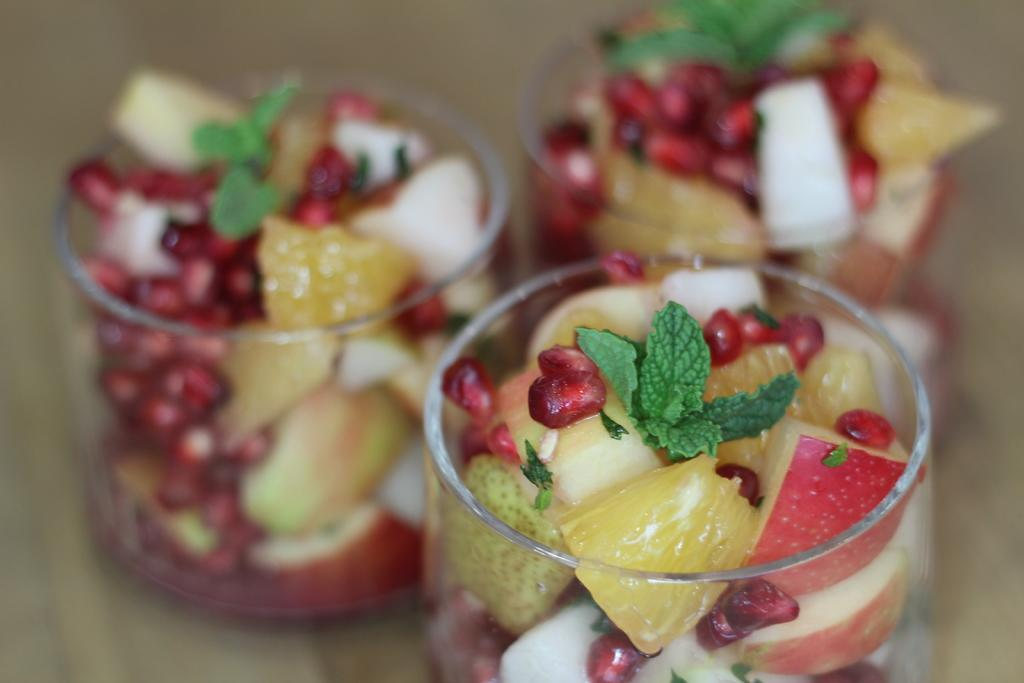How many bowls are visible in the image? There are three bowls in the image. What is inside the bowls? The bowls contain fruit salads. Where are the bowls located? The bowls are placed on a table. Can you describe the background of the image? The background of the image is blurred. What grade does the fruit salad receive in the image? There is no indication of a grade or evaluation in the image; it simply shows three bowls containing fruit salads. 